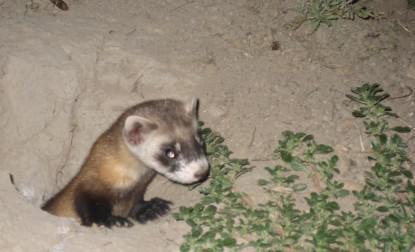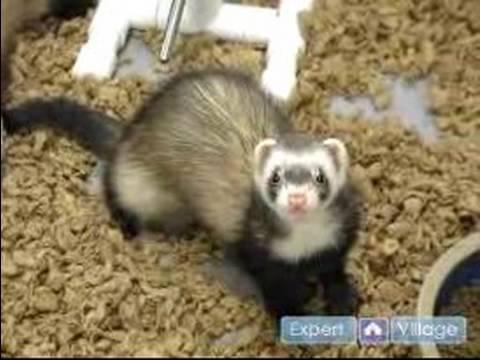The first image is the image on the left, the second image is the image on the right. For the images displayed, is the sentence "The Muscatel is partly viable as they come out of the dirt hole in the ground." factually correct? Answer yes or no. Yes. 